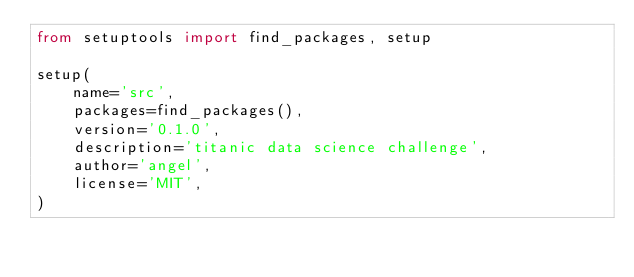<code> <loc_0><loc_0><loc_500><loc_500><_Python_>from setuptools import find_packages, setup

setup(
    name='src',
    packages=find_packages(),
    version='0.1.0',
    description='titanic data science challenge',
    author='angel',
    license='MIT',
)
</code> 